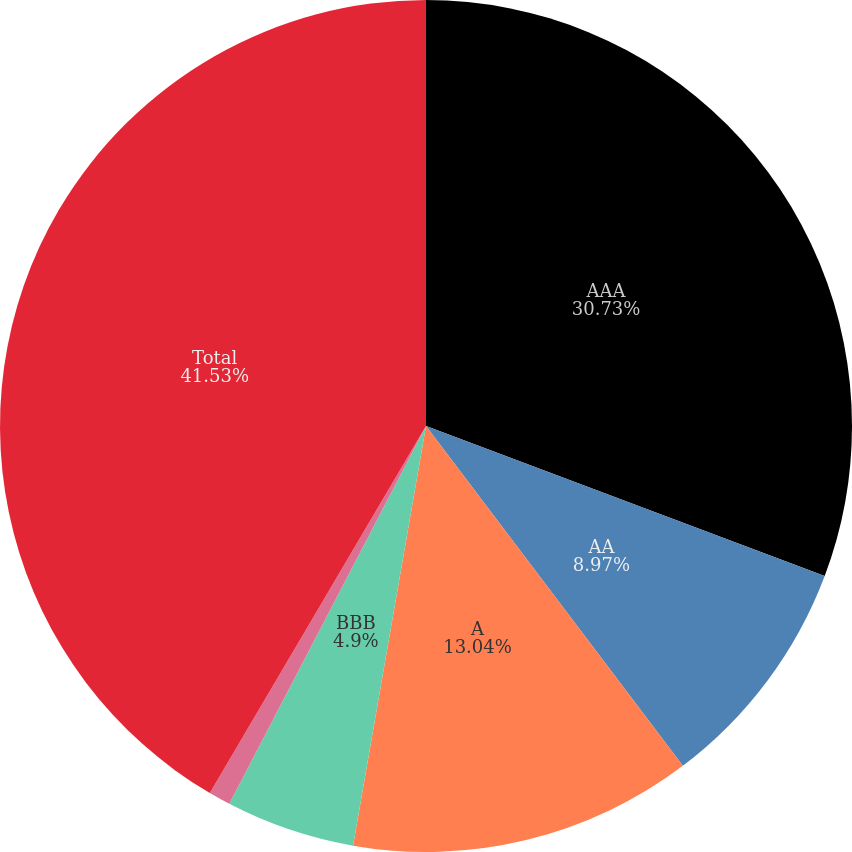<chart> <loc_0><loc_0><loc_500><loc_500><pie_chart><fcel>AAA<fcel>AA<fcel>A<fcel>BBB<fcel>Below investment grade<fcel>Total<nl><fcel>30.73%<fcel>8.97%<fcel>13.04%<fcel>4.9%<fcel>0.83%<fcel>41.53%<nl></chart> 